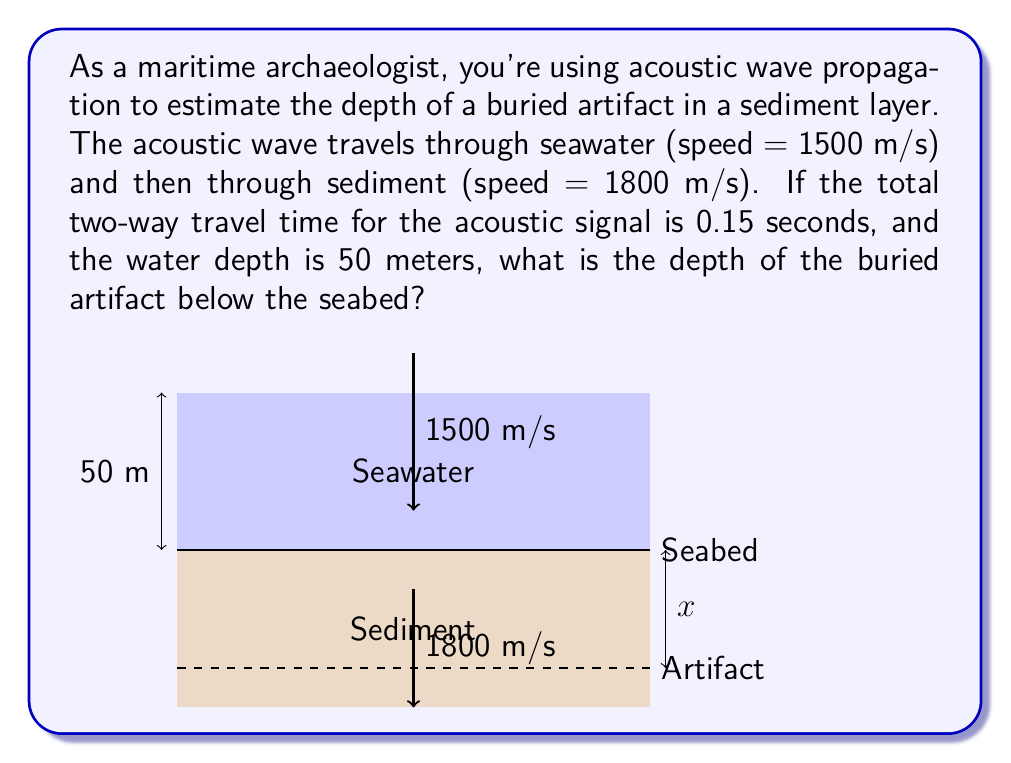Solve this math problem. Let's approach this step-by-step:

1) Let the depth of the artifact below the seabed be $x$ meters.

2) The total travel time ($t$) is the sum of time in water ($t_w$) and time in sediment ($t_s$):
   $$t = t_w + t_s = 0.15\text{ s}$$

3) For the water portion:
   $$t_w = \frac{2 \times 50\text{ m}}{1500\text{ m/s}} = \frac{1}{15}\text{ s}$$

4) For the sediment portion:
   $$t_s = \frac{2x}{1800\text{ m/s}}$$

5) Substituting into the total time equation:
   $$0.15 = \frac{1}{15} + \frac{2x}{1800}$$

6) Solving for $x$:
   $$0.15 - \frac{1}{15} = \frac{2x}{1800}$$
   $$0.15 - 0.0667 = \frac{2x}{1800}$$
   $$0.0833 = \frac{2x}{1800}$$
   $$x = 0.0833 \times 900 = 75\text{ m}$$

Therefore, the artifact is buried 75 meters below the seabed.
Answer: 75 meters 